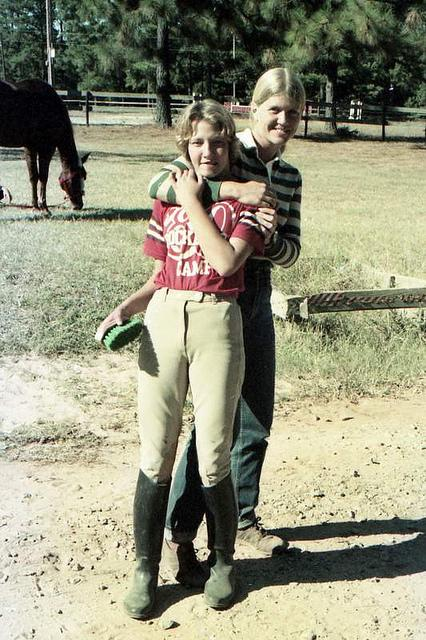What will she use the brush for?

Choices:
A) brush horse
B) brush hair
C) sweep ground
D) clean shoes brush horse 